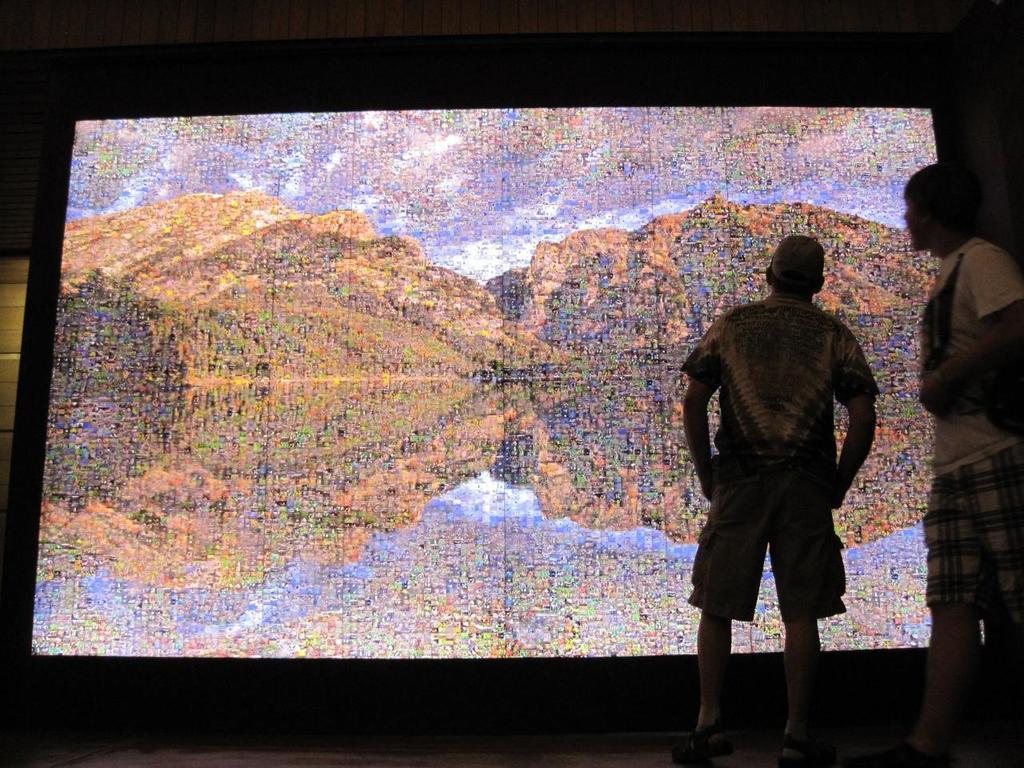Could you give a brief overview of what you see in this image? In this image there are two men standing towards the bottom of the image, there is a man wearing a cap, there is a screen, there is water, there is a tree, there are mountains, there is the sky, there is a wall towards the top of the image. 